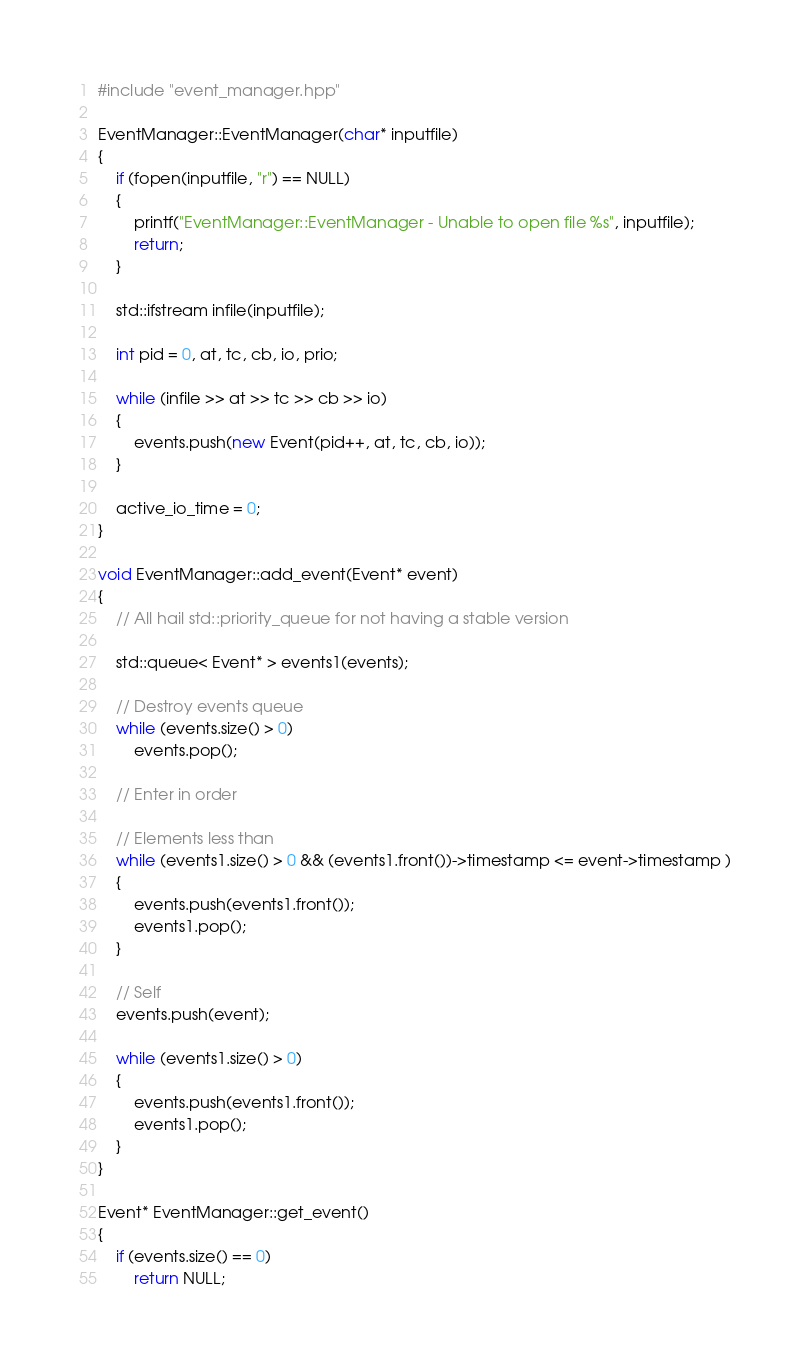Convert code to text. <code><loc_0><loc_0><loc_500><loc_500><_C++_>#include "event_manager.hpp"

EventManager::EventManager(char* inputfile)
{
    if (fopen(inputfile, "r") == NULL)
    {
        printf("EventManager::EventManager - Unable to open file %s", inputfile);
        return;
    }

    std::ifstream infile(inputfile);

    int pid = 0, at, tc, cb, io, prio;

    while (infile >> at >> tc >> cb >> io)
    {
        events.push(new Event(pid++, at, tc, cb, io));
    }

    active_io_time = 0;
}

void EventManager::add_event(Event* event)
{
    // All hail std::priority_queue for not having a stable version
    
    std::queue< Event* > events1(events);

    // Destroy events queue
    while (events.size() > 0)
        events.pop();

    // Enter in order

    // Elements less than
    while (events1.size() > 0 && (events1.front())->timestamp <= event->timestamp )
    {
        events.push(events1.front());
        events1.pop();
    }

    // Self
    events.push(event);

    while (events1.size() > 0)
    {
        events.push(events1.front());
        events1.pop();
    }
}

Event* EventManager::get_event()
{
    if (events.size() == 0)
        return NULL;
</code> 